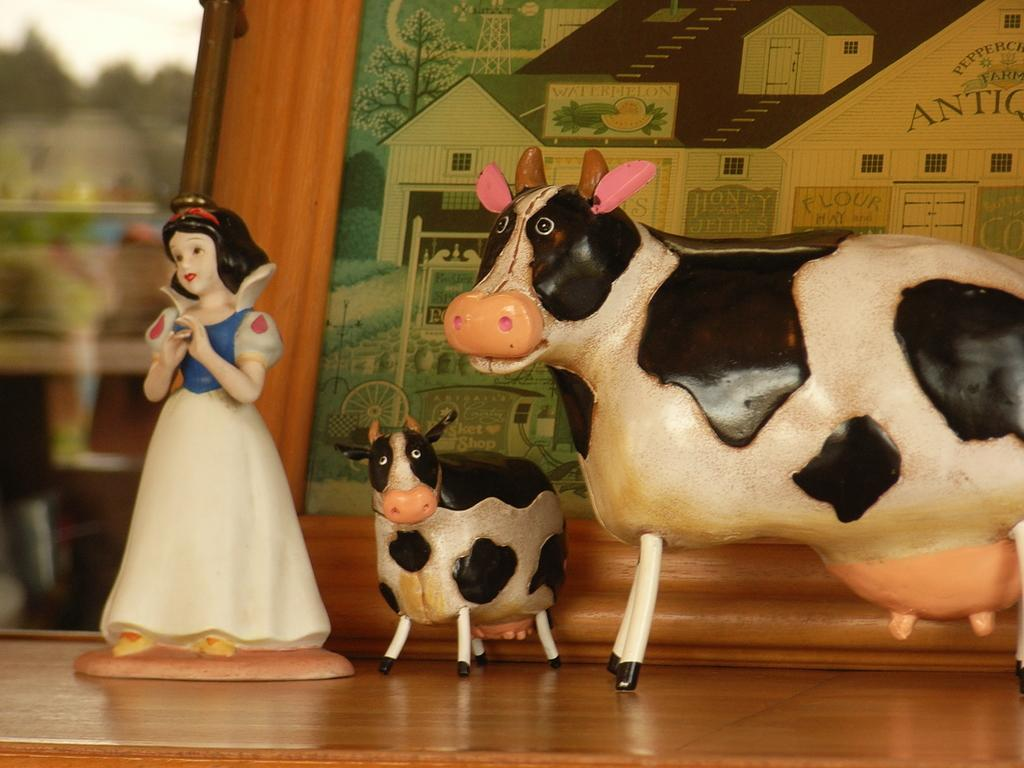What is the main subject in the center of the image? There is a depiction of cows in the center of the image. Can you describe another subject in the image? There is a depiction of a girl on a table in the image. What unit of measurement is used to describe the temperature of the hot discovery in the image? There is no mention of a hot discovery or any unit of measurement in the image. 